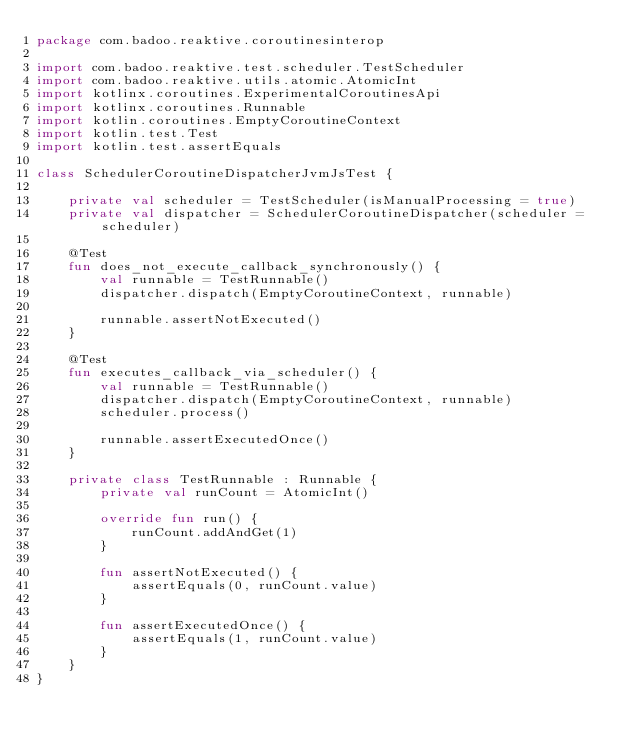Convert code to text. <code><loc_0><loc_0><loc_500><loc_500><_Kotlin_>package com.badoo.reaktive.coroutinesinterop

import com.badoo.reaktive.test.scheduler.TestScheduler
import com.badoo.reaktive.utils.atomic.AtomicInt
import kotlinx.coroutines.ExperimentalCoroutinesApi
import kotlinx.coroutines.Runnable
import kotlin.coroutines.EmptyCoroutineContext
import kotlin.test.Test
import kotlin.test.assertEquals

class SchedulerCoroutineDispatcherJvmJsTest {

    private val scheduler = TestScheduler(isManualProcessing = true)
    private val dispatcher = SchedulerCoroutineDispatcher(scheduler = scheduler)

    @Test
    fun does_not_execute_callback_synchronously() {
        val runnable = TestRunnable()
        dispatcher.dispatch(EmptyCoroutineContext, runnable)

        runnable.assertNotExecuted()
    }

    @Test
    fun executes_callback_via_scheduler() {
        val runnable = TestRunnable()
        dispatcher.dispatch(EmptyCoroutineContext, runnable)
        scheduler.process()

        runnable.assertExecutedOnce()
    }

    private class TestRunnable : Runnable {
        private val runCount = AtomicInt()

        override fun run() {
            runCount.addAndGet(1)
        }

        fun assertNotExecuted() {
            assertEquals(0, runCount.value)
        }

        fun assertExecutedOnce() {
            assertEquals(1, runCount.value)
        }
    }
}
</code> 